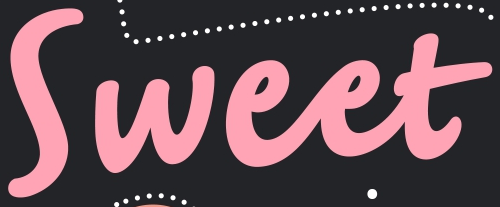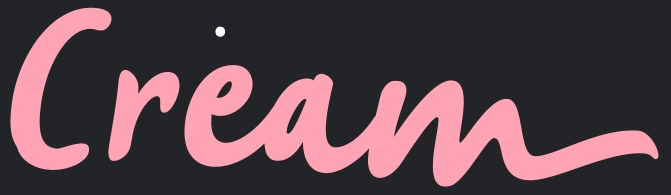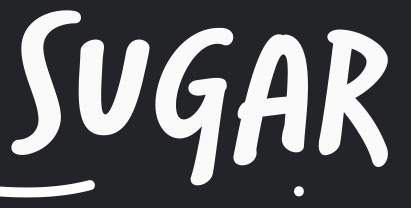Read the text content from these images in order, separated by a semicolon. Sweet; Cream; SUGAR 